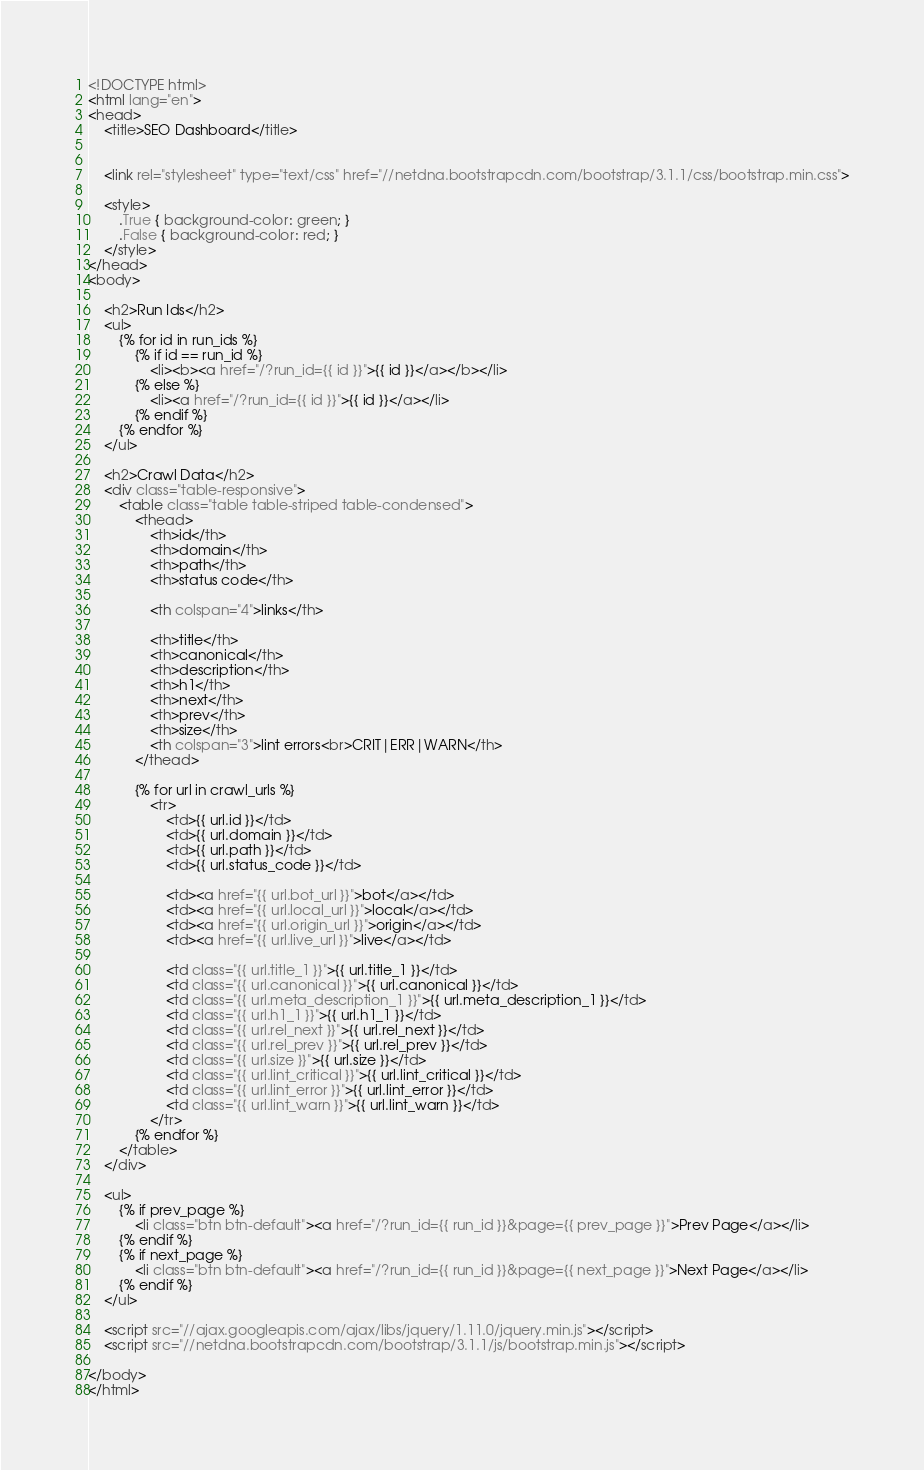<code> <loc_0><loc_0><loc_500><loc_500><_HTML_><!DOCTYPE html>
<html lang="en">
<head>
    <title>SEO Dashboard</title>


    <link rel="stylesheet" type="text/css" href="//netdna.bootstrapcdn.com/bootstrap/3.1.1/css/bootstrap.min.css">

    <style>
        .True { background-color: green; }
        .False { background-color: red; }
    </style>
</head>
<body>

    <h2>Run Ids</h2>
    <ul>
        {% for id in run_ids %}
            {% if id == run_id %}
                <li><b><a href="/?run_id={{ id }}">{{ id }}</a></b></li>
            {% else %}
                <li><a href="/?run_id={{ id }}">{{ id }}</a></li>
            {% endif %}
        {% endfor %}
    </ul>

    <h2>Crawl Data</h2>
    <div class="table-responsive">
        <table class="table table-striped table-condensed">
            <thead>
                <th>id</th>
                <th>domain</th>
                <th>path</th>
                <th>status code</th>

                <th colspan="4">links</th>

                <th>title</th>
                <th>canonical</th>
                <th>description</th>
                <th>h1</th>
                <th>next</th>
                <th>prev</th>
                <th>size</th>
                <th colspan="3">lint errors<br>CRIT|ERR|WARN</th>
            </thead>

            {% for url in crawl_urls %}
                <tr>
                    <td>{{ url.id }}</td>
                    <td>{{ url.domain }}</td>
                    <td>{{ url.path }}</td>
                    <td>{{ url.status_code }}</td>

                    <td><a href="{{ url.bot_url }}">bot</a></td>
                    <td><a href="{{ url.local_url }}">local</a></td>
                    <td><a href="{{ url.origin_url }}">origin</a></td>
                    <td><a href="{{ url.live_url }}">live</a></td>

                    <td class="{{ url.title_1 }}">{{ url.title_1 }}</td>
                    <td class="{{ url.canonical }}">{{ url.canonical }}</td>
                    <td class="{{ url.meta_description_1 }}">{{ url.meta_description_1 }}</td>
                    <td class="{{ url.h1_1 }}">{{ url.h1_1 }}</td>
                    <td class="{{ url.rel_next }}">{{ url.rel_next }}</td>
                    <td class="{{ url.rel_prev }}">{{ url.rel_prev }}</td>
                    <td class="{{ url.size }}">{{ url.size }}</td>
                    <td class="{{ url.lint_critical }}">{{ url.lint_critical }}</td>
                    <td class="{{ url.lint_error }}">{{ url.lint_error }}</td>
                    <td class="{{ url.lint_warn }}">{{ url.lint_warn }}</td>
                </tr>
            {% endfor %}
        </table>
    </div>

    <ul>
        {% if prev_page %}
            <li class="btn btn-default"><a href="/?run_id={{ run_id }}&page={{ prev_page }}">Prev Page</a></li>
        {% endif %}
        {% if next_page %}
            <li class="btn btn-default"><a href="/?run_id={{ run_id }}&page={{ next_page }}">Next Page</a></li>
        {% endif %}
    </ul>

    <script src="//ajax.googleapis.com/ajax/libs/jquery/1.11.0/jquery.min.js"></script>
    <script src="//netdna.bootstrapcdn.com/bootstrap/3.1.1/js/bootstrap.min.js"></script>

</body>
</html></code> 